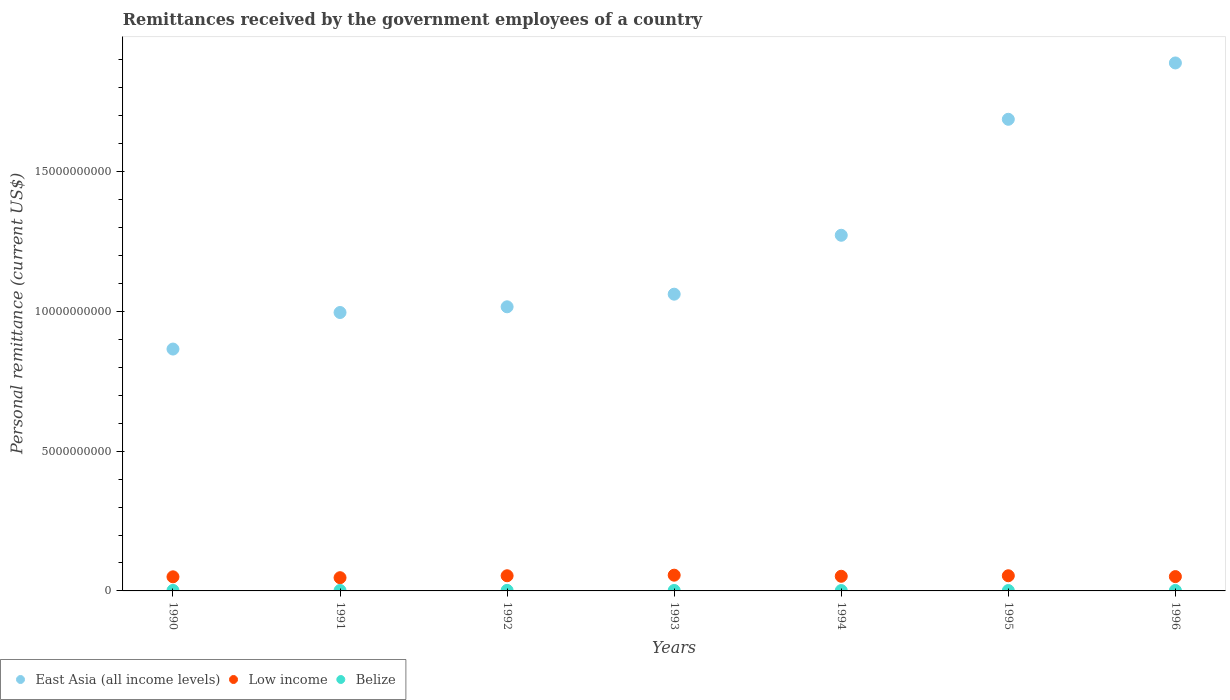How many different coloured dotlines are there?
Your response must be concise. 3. Is the number of dotlines equal to the number of legend labels?
Keep it short and to the point. Yes. What is the remittances received by the government employees in East Asia (all income levels) in 1995?
Your answer should be very brief. 1.69e+1. Across all years, what is the maximum remittances received by the government employees in East Asia (all income levels)?
Your answer should be very brief. 1.89e+1. Across all years, what is the minimum remittances received by the government employees in Belize?
Ensure brevity in your answer.  1.30e+07. What is the total remittances received by the government employees in Low income in the graph?
Offer a terse response. 3.66e+09. What is the difference between the remittances received by the government employees in East Asia (all income levels) in 1992 and that in 1993?
Your response must be concise. -4.52e+08. What is the difference between the remittances received by the government employees in Low income in 1991 and the remittances received by the government employees in Belize in 1990?
Provide a succinct answer. 4.55e+08. What is the average remittances received by the government employees in Low income per year?
Give a very brief answer. 5.23e+08. In the year 1992, what is the difference between the remittances received by the government employees in Low income and remittances received by the government employees in Belize?
Give a very brief answer. 5.23e+08. What is the ratio of the remittances received by the government employees in East Asia (all income levels) in 1993 to that in 1994?
Your response must be concise. 0.83. What is the difference between the highest and the second highest remittances received by the government employees in Low income?
Ensure brevity in your answer.  2.03e+07. What is the difference between the highest and the lowest remittances received by the government employees in Low income?
Your response must be concise. 8.98e+07. Is the sum of the remittances received by the government employees in East Asia (all income levels) in 1990 and 1992 greater than the maximum remittances received by the government employees in Belize across all years?
Your answer should be compact. Yes. Is it the case that in every year, the sum of the remittances received by the government employees in East Asia (all income levels) and remittances received by the government employees in Belize  is greater than the remittances received by the government employees in Low income?
Keep it short and to the point. Yes. Does the remittances received by the government employees in Belize monotonically increase over the years?
Your answer should be very brief. No. Is the remittances received by the government employees in Belize strictly less than the remittances received by the government employees in East Asia (all income levels) over the years?
Your answer should be very brief. Yes. How many dotlines are there?
Provide a short and direct response. 3. How many years are there in the graph?
Offer a very short reply. 7. Does the graph contain grids?
Offer a very short reply. No. Where does the legend appear in the graph?
Ensure brevity in your answer.  Bottom left. How many legend labels are there?
Your answer should be compact. 3. What is the title of the graph?
Keep it short and to the point. Remittances received by the government employees of a country. What is the label or title of the X-axis?
Keep it short and to the point. Years. What is the label or title of the Y-axis?
Keep it short and to the point. Personal remittance (current US$). What is the Personal remittance (current US$) in East Asia (all income levels) in 1990?
Provide a succinct answer. 8.65e+09. What is the Personal remittance (current US$) in Low income in 1990?
Your response must be concise. 5.04e+08. What is the Personal remittance (current US$) of Belize in 1990?
Provide a succinct answer. 1.85e+07. What is the Personal remittance (current US$) of East Asia (all income levels) in 1991?
Provide a succinct answer. 9.96e+09. What is the Personal remittance (current US$) of Low income in 1991?
Keep it short and to the point. 4.73e+08. What is the Personal remittance (current US$) of Belize in 1991?
Offer a very short reply. 1.56e+07. What is the Personal remittance (current US$) of East Asia (all income levels) in 1992?
Offer a terse response. 1.02e+1. What is the Personal remittance (current US$) of Low income in 1992?
Offer a terse response. 5.43e+08. What is the Personal remittance (current US$) of Belize in 1992?
Your answer should be compact. 1.98e+07. What is the Personal remittance (current US$) in East Asia (all income levels) in 1993?
Provide a short and direct response. 1.06e+1. What is the Personal remittance (current US$) of Low income in 1993?
Your answer should be very brief. 5.63e+08. What is the Personal remittance (current US$) in Belize in 1993?
Offer a very short reply. 1.65e+07. What is the Personal remittance (current US$) in East Asia (all income levels) in 1994?
Offer a terse response. 1.27e+1. What is the Personal remittance (current US$) in Low income in 1994?
Provide a short and direct response. 5.24e+08. What is the Personal remittance (current US$) in Belize in 1994?
Give a very brief answer. 1.30e+07. What is the Personal remittance (current US$) in East Asia (all income levels) in 1995?
Keep it short and to the point. 1.69e+1. What is the Personal remittance (current US$) of Low income in 1995?
Offer a terse response. 5.43e+08. What is the Personal remittance (current US$) in Belize in 1995?
Offer a terse response. 1.39e+07. What is the Personal remittance (current US$) of East Asia (all income levels) in 1996?
Provide a succinct answer. 1.89e+1. What is the Personal remittance (current US$) of Low income in 1996?
Provide a short and direct response. 5.12e+08. What is the Personal remittance (current US$) of Belize in 1996?
Offer a very short reply. 1.72e+07. Across all years, what is the maximum Personal remittance (current US$) of East Asia (all income levels)?
Ensure brevity in your answer.  1.89e+1. Across all years, what is the maximum Personal remittance (current US$) in Low income?
Offer a terse response. 5.63e+08. Across all years, what is the maximum Personal remittance (current US$) of Belize?
Your answer should be compact. 1.98e+07. Across all years, what is the minimum Personal remittance (current US$) of East Asia (all income levels)?
Your answer should be very brief. 8.65e+09. Across all years, what is the minimum Personal remittance (current US$) of Low income?
Offer a terse response. 4.73e+08. Across all years, what is the minimum Personal remittance (current US$) in Belize?
Offer a terse response. 1.30e+07. What is the total Personal remittance (current US$) of East Asia (all income levels) in the graph?
Ensure brevity in your answer.  8.79e+1. What is the total Personal remittance (current US$) of Low income in the graph?
Ensure brevity in your answer.  3.66e+09. What is the total Personal remittance (current US$) of Belize in the graph?
Give a very brief answer. 1.14e+08. What is the difference between the Personal remittance (current US$) of East Asia (all income levels) in 1990 and that in 1991?
Offer a terse response. -1.31e+09. What is the difference between the Personal remittance (current US$) of Low income in 1990 and that in 1991?
Offer a terse response. 3.10e+07. What is the difference between the Personal remittance (current US$) in Belize in 1990 and that in 1991?
Ensure brevity in your answer.  2.85e+06. What is the difference between the Personal remittance (current US$) of East Asia (all income levels) in 1990 and that in 1992?
Provide a succinct answer. -1.51e+09. What is the difference between the Personal remittance (current US$) in Low income in 1990 and that in 1992?
Make the answer very short. -3.84e+07. What is the difference between the Personal remittance (current US$) in Belize in 1990 and that in 1992?
Your answer should be compact. -1.30e+06. What is the difference between the Personal remittance (current US$) of East Asia (all income levels) in 1990 and that in 1993?
Your answer should be very brief. -1.96e+09. What is the difference between the Personal remittance (current US$) of Low income in 1990 and that in 1993?
Your response must be concise. -5.88e+07. What is the difference between the Personal remittance (current US$) of Belize in 1990 and that in 1993?
Provide a short and direct response. 1.95e+06. What is the difference between the Personal remittance (current US$) of East Asia (all income levels) in 1990 and that in 1994?
Provide a short and direct response. -4.07e+09. What is the difference between the Personal remittance (current US$) of Low income in 1990 and that in 1994?
Give a very brief answer. -1.96e+07. What is the difference between the Personal remittance (current US$) in Belize in 1990 and that in 1994?
Make the answer very short. 5.48e+06. What is the difference between the Personal remittance (current US$) in East Asia (all income levels) in 1990 and that in 1995?
Offer a terse response. -8.22e+09. What is the difference between the Personal remittance (current US$) in Low income in 1990 and that in 1995?
Offer a very short reply. -3.85e+07. What is the difference between the Personal remittance (current US$) of Belize in 1990 and that in 1995?
Ensure brevity in your answer.  4.55e+06. What is the difference between the Personal remittance (current US$) in East Asia (all income levels) in 1990 and that in 1996?
Ensure brevity in your answer.  -1.02e+1. What is the difference between the Personal remittance (current US$) in Low income in 1990 and that in 1996?
Make the answer very short. -8.04e+06. What is the difference between the Personal remittance (current US$) of Belize in 1990 and that in 1996?
Give a very brief answer. 1.20e+06. What is the difference between the Personal remittance (current US$) of East Asia (all income levels) in 1991 and that in 1992?
Provide a succinct answer. -2.04e+08. What is the difference between the Personal remittance (current US$) in Low income in 1991 and that in 1992?
Your response must be concise. -6.94e+07. What is the difference between the Personal remittance (current US$) in Belize in 1991 and that in 1992?
Your answer should be very brief. -4.15e+06. What is the difference between the Personal remittance (current US$) in East Asia (all income levels) in 1991 and that in 1993?
Your answer should be compact. -6.56e+08. What is the difference between the Personal remittance (current US$) of Low income in 1991 and that in 1993?
Make the answer very short. -8.98e+07. What is the difference between the Personal remittance (current US$) in Belize in 1991 and that in 1993?
Offer a very short reply. -9.00e+05. What is the difference between the Personal remittance (current US$) in East Asia (all income levels) in 1991 and that in 1994?
Offer a very short reply. -2.76e+09. What is the difference between the Personal remittance (current US$) in Low income in 1991 and that in 1994?
Give a very brief answer. -5.06e+07. What is the difference between the Personal remittance (current US$) in Belize in 1991 and that in 1994?
Your answer should be compact. 2.63e+06. What is the difference between the Personal remittance (current US$) in East Asia (all income levels) in 1991 and that in 1995?
Your answer should be compact. -6.91e+09. What is the difference between the Personal remittance (current US$) in Low income in 1991 and that in 1995?
Provide a short and direct response. -6.95e+07. What is the difference between the Personal remittance (current US$) of Belize in 1991 and that in 1995?
Give a very brief answer. 1.70e+06. What is the difference between the Personal remittance (current US$) in East Asia (all income levels) in 1991 and that in 1996?
Your answer should be compact. -8.93e+09. What is the difference between the Personal remittance (current US$) in Low income in 1991 and that in 1996?
Offer a very short reply. -3.91e+07. What is the difference between the Personal remittance (current US$) in Belize in 1991 and that in 1996?
Make the answer very short. -1.65e+06. What is the difference between the Personal remittance (current US$) in East Asia (all income levels) in 1992 and that in 1993?
Provide a succinct answer. -4.52e+08. What is the difference between the Personal remittance (current US$) in Low income in 1992 and that in 1993?
Your response must be concise. -2.04e+07. What is the difference between the Personal remittance (current US$) of Belize in 1992 and that in 1993?
Ensure brevity in your answer.  3.25e+06. What is the difference between the Personal remittance (current US$) in East Asia (all income levels) in 1992 and that in 1994?
Provide a short and direct response. -2.56e+09. What is the difference between the Personal remittance (current US$) of Low income in 1992 and that in 1994?
Your answer should be compact. 1.88e+07. What is the difference between the Personal remittance (current US$) of Belize in 1992 and that in 1994?
Keep it short and to the point. 6.78e+06. What is the difference between the Personal remittance (current US$) in East Asia (all income levels) in 1992 and that in 1995?
Ensure brevity in your answer.  -6.71e+09. What is the difference between the Personal remittance (current US$) of Low income in 1992 and that in 1995?
Provide a succinct answer. -9.84e+04. What is the difference between the Personal remittance (current US$) of Belize in 1992 and that in 1995?
Provide a short and direct response. 5.85e+06. What is the difference between the Personal remittance (current US$) in East Asia (all income levels) in 1992 and that in 1996?
Provide a succinct answer. -8.73e+09. What is the difference between the Personal remittance (current US$) in Low income in 1992 and that in 1996?
Give a very brief answer. 3.03e+07. What is the difference between the Personal remittance (current US$) of Belize in 1992 and that in 1996?
Your answer should be very brief. 2.50e+06. What is the difference between the Personal remittance (current US$) in East Asia (all income levels) in 1993 and that in 1994?
Give a very brief answer. -2.11e+09. What is the difference between the Personal remittance (current US$) of Low income in 1993 and that in 1994?
Offer a very short reply. 3.92e+07. What is the difference between the Personal remittance (current US$) in Belize in 1993 and that in 1994?
Your response must be concise. 3.53e+06. What is the difference between the Personal remittance (current US$) of East Asia (all income levels) in 1993 and that in 1995?
Ensure brevity in your answer.  -6.26e+09. What is the difference between the Personal remittance (current US$) of Low income in 1993 and that in 1995?
Ensure brevity in your answer.  2.03e+07. What is the difference between the Personal remittance (current US$) of Belize in 1993 and that in 1995?
Provide a succinct answer. 2.60e+06. What is the difference between the Personal remittance (current US$) of East Asia (all income levels) in 1993 and that in 1996?
Offer a terse response. -8.27e+09. What is the difference between the Personal remittance (current US$) in Low income in 1993 and that in 1996?
Offer a terse response. 5.07e+07. What is the difference between the Personal remittance (current US$) of Belize in 1993 and that in 1996?
Keep it short and to the point. -7.50e+05. What is the difference between the Personal remittance (current US$) of East Asia (all income levels) in 1994 and that in 1995?
Your answer should be very brief. -4.15e+09. What is the difference between the Personal remittance (current US$) of Low income in 1994 and that in 1995?
Offer a very short reply. -1.89e+07. What is the difference between the Personal remittance (current US$) in Belize in 1994 and that in 1995?
Provide a short and direct response. -9.28e+05. What is the difference between the Personal remittance (current US$) in East Asia (all income levels) in 1994 and that in 1996?
Keep it short and to the point. -6.17e+09. What is the difference between the Personal remittance (current US$) of Low income in 1994 and that in 1996?
Your answer should be compact. 1.15e+07. What is the difference between the Personal remittance (current US$) of Belize in 1994 and that in 1996?
Offer a terse response. -4.28e+06. What is the difference between the Personal remittance (current US$) in East Asia (all income levels) in 1995 and that in 1996?
Give a very brief answer. -2.02e+09. What is the difference between the Personal remittance (current US$) of Low income in 1995 and that in 1996?
Make the answer very short. 3.04e+07. What is the difference between the Personal remittance (current US$) of Belize in 1995 and that in 1996?
Your answer should be compact. -3.35e+06. What is the difference between the Personal remittance (current US$) of East Asia (all income levels) in 1990 and the Personal remittance (current US$) of Low income in 1991?
Offer a terse response. 8.18e+09. What is the difference between the Personal remittance (current US$) of East Asia (all income levels) in 1990 and the Personal remittance (current US$) of Belize in 1991?
Offer a terse response. 8.64e+09. What is the difference between the Personal remittance (current US$) in Low income in 1990 and the Personal remittance (current US$) in Belize in 1991?
Make the answer very short. 4.89e+08. What is the difference between the Personal remittance (current US$) of East Asia (all income levels) in 1990 and the Personal remittance (current US$) of Low income in 1992?
Provide a short and direct response. 8.11e+09. What is the difference between the Personal remittance (current US$) in East Asia (all income levels) in 1990 and the Personal remittance (current US$) in Belize in 1992?
Provide a succinct answer. 8.63e+09. What is the difference between the Personal remittance (current US$) of Low income in 1990 and the Personal remittance (current US$) of Belize in 1992?
Your answer should be very brief. 4.85e+08. What is the difference between the Personal remittance (current US$) of East Asia (all income levels) in 1990 and the Personal remittance (current US$) of Low income in 1993?
Give a very brief answer. 8.09e+09. What is the difference between the Personal remittance (current US$) of East Asia (all income levels) in 1990 and the Personal remittance (current US$) of Belize in 1993?
Your response must be concise. 8.64e+09. What is the difference between the Personal remittance (current US$) in Low income in 1990 and the Personal remittance (current US$) in Belize in 1993?
Make the answer very short. 4.88e+08. What is the difference between the Personal remittance (current US$) of East Asia (all income levels) in 1990 and the Personal remittance (current US$) of Low income in 1994?
Give a very brief answer. 8.13e+09. What is the difference between the Personal remittance (current US$) in East Asia (all income levels) in 1990 and the Personal remittance (current US$) in Belize in 1994?
Give a very brief answer. 8.64e+09. What is the difference between the Personal remittance (current US$) of Low income in 1990 and the Personal remittance (current US$) of Belize in 1994?
Provide a short and direct response. 4.91e+08. What is the difference between the Personal remittance (current US$) in East Asia (all income levels) in 1990 and the Personal remittance (current US$) in Low income in 1995?
Your answer should be very brief. 8.11e+09. What is the difference between the Personal remittance (current US$) in East Asia (all income levels) in 1990 and the Personal remittance (current US$) in Belize in 1995?
Offer a terse response. 8.64e+09. What is the difference between the Personal remittance (current US$) in Low income in 1990 and the Personal remittance (current US$) in Belize in 1995?
Make the answer very short. 4.90e+08. What is the difference between the Personal remittance (current US$) of East Asia (all income levels) in 1990 and the Personal remittance (current US$) of Low income in 1996?
Ensure brevity in your answer.  8.14e+09. What is the difference between the Personal remittance (current US$) in East Asia (all income levels) in 1990 and the Personal remittance (current US$) in Belize in 1996?
Keep it short and to the point. 8.64e+09. What is the difference between the Personal remittance (current US$) in Low income in 1990 and the Personal remittance (current US$) in Belize in 1996?
Keep it short and to the point. 4.87e+08. What is the difference between the Personal remittance (current US$) in East Asia (all income levels) in 1991 and the Personal remittance (current US$) in Low income in 1992?
Keep it short and to the point. 9.42e+09. What is the difference between the Personal remittance (current US$) of East Asia (all income levels) in 1991 and the Personal remittance (current US$) of Belize in 1992?
Your answer should be very brief. 9.94e+09. What is the difference between the Personal remittance (current US$) in Low income in 1991 and the Personal remittance (current US$) in Belize in 1992?
Your response must be concise. 4.54e+08. What is the difference between the Personal remittance (current US$) of East Asia (all income levels) in 1991 and the Personal remittance (current US$) of Low income in 1993?
Keep it short and to the point. 9.40e+09. What is the difference between the Personal remittance (current US$) of East Asia (all income levels) in 1991 and the Personal remittance (current US$) of Belize in 1993?
Give a very brief answer. 9.95e+09. What is the difference between the Personal remittance (current US$) of Low income in 1991 and the Personal remittance (current US$) of Belize in 1993?
Your answer should be compact. 4.57e+08. What is the difference between the Personal remittance (current US$) in East Asia (all income levels) in 1991 and the Personal remittance (current US$) in Low income in 1994?
Keep it short and to the point. 9.44e+09. What is the difference between the Personal remittance (current US$) of East Asia (all income levels) in 1991 and the Personal remittance (current US$) of Belize in 1994?
Provide a short and direct response. 9.95e+09. What is the difference between the Personal remittance (current US$) of Low income in 1991 and the Personal remittance (current US$) of Belize in 1994?
Your answer should be compact. 4.60e+08. What is the difference between the Personal remittance (current US$) of East Asia (all income levels) in 1991 and the Personal remittance (current US$) of Low income in 1995?
Your answer should be compact. 9.42e+09. What is the difference between the Personal remittance (current US$) of East Asia (all income levels) in 1991 and the Personal remittance (current US$) of Belize in 1995?
Ensure brevity in your answer.  9.95e+09. What is the difference between the Personal remittance (current US$) in Low income in 1991 and the Personal remittance (current US$) in Belize in 1995?
Offer a terse response. 4.59e+08. What is the difference between the Personal remittance (current US$) in East Asia (all income levels) in 1991 and the Personal remittance (current US$) in Low income in 1996?
Ensure brevity in your answer.  9.45e+09. What is the difference between the Personal remittance (current US$) of East Asia (all income levels) in 1991 and the Personal remittance (current US$) of Belize in 1996?
Provide a succinct answer. 9.94e+09. What is the difference between the Personal remittance (current US$) of Low income in 1991 and the Personal remittance (current US$) of Belize in 1996?
Provide a short and direct response. 4.56e+08. What is the difference between the Personal remittance (current US$) in East Asia (all income levels) in 1992 and the Personal remittance (current US$) in Low income in 1993?
Ensure brevity in your answer.  9.60e+09. What is the difference between the Personal remittance (current US$) in East Asia (all income levels) in 1992 and the Personal remittance (current US$) in Belize in 1993?
Provide a succinct answer. 1.01e+1. What is the difference between the Personal remittance (current US$) of Low income in 1992 and the Personal remittance (current US$) of Belize in 1993?
Your answer should be very brief. 5.26e+08. What is the difference between the Personal remittance (current US$) in East Asia (all income levels) in 1992 and the Personal remittance (current US$) in Low income in 1994?
Keep it short and to the point. 9.64e+09. What is the difference between the Personal remittance (current US$) in East Asia (all income levels) in 1992 and the Personal remittance (current US$) in Belize in 1994?
Make the answer very short. 1.02e+1. What is the difference between the Personal remittance (current US$) in Low income in 1992 and the Personal remittance (current US$) in Belize in 1994?
Keep it short and to the point. 5.30e+08. What is the difference between the Personal remittance (current US$) of East Asia (all income levels) in 1992 and the Personal remittance (current US$) of Low income in 1995?
Ensure brevity in your answer.  9.62e+09. What is the difference between the Personal remittance (current US$) in East Asia (all income levels) in 1992 and the Personal remittance (current US$) in Belize in 1995?
Ensure brevity in your answer.  1.02e+1. What is the difference between the Personal remittance (current US$) of Low income in 1992 and the Personal remittance (current US$) of Belize in 1995?
Keep it short and to the point. 5.29e+08. What is the difference between the Personal remittance (current US$) of East Asia (all income levels) in 1992 and the Personal remittance (current US$) of Low income in 1996?
Provide a short and direct response. 9.65e+09. What is the difference between the Personal remittance (current US$) in East Asia (all income levels) in 1992 and the Personal remittance (current US$) in Belize in 1996?
Offer a very short reply. 1.01e+1. What is the difference between the Personal remittance (current US$) of Low income in 1992 and the Personal remittance (current US$) of Belize in 1996?
Your response must be concise. 5.25e+08. What is the difference between the Personal remittance (current US$) of East Asia (all income levels) in 1993 and the Personal remittance (current US$) of Low income in 1994?
Ensure brevity in your answer.  1.01e+1. What is the difference between the Personal remittance (current US$) in East Asia (all income levels) in 1993 and the Personal remittance (current US$) in Belize in 1994?
Keep it short and to the point. 1.06e+1. What is the difference between the Personal remittance (current US$) in Low income in 1993 and the Personal remittance (current US$) in Belize in 1994?
Offer a terse response. 5.50e+08. What is the difference between the Personal remittance (current US$) of East Asia (all income levels) in 1993 and the Personal remittance (current US$) of Low income in 1995?
Keep it short and to the point. 1.01e+1. What is the difference between the Personal remittance (current US$) of East Asia (all income levels) in 1993 and the Personal remittance (current US$) of Belize in 1995?
Keep it short and to the point. 1.06e+1. What is the difference between the Personal remittance (current US$) in Low income in 1993 and the Personal remittance (current US$) in Belize in 1995?
Make the answer very short. 5.49e+08. What is the difference between the Personal remittance (current US$) in East Asia (all income levels) in 1993 and the Personal remittance (current US$) in Low income in 1996?
Your answer should be very brief. 1.01e+1. What is the difference between the Personal remittance (current US$) of East Asia (all income levels) in 1993 and the Personal remittance (current US$) of Belize in 1996?
Make the answer very short. 1.06e+1. What is the difference between the Personal remittance (current US$) of Low income in 1993 and the Personal remittance (current US$) of Belize in 1996?
Provide a succinct answer. 5.46e+08. What is the difference between the Personal remittance (current US$) of East Asia (all income levels) in 1994 and the Personal remittance (current US$) of Low income in 1995?
Offer a very short reply. 1.22e+1. What is the difference between the Personal remittance (current US$) of East Asia (all income levels) in 1994 and the Personal remittance (current US$) of Belize in 1995?
Keep it short and to the point. 1.27e+1. What is the difference between the Personal remittance (current US$) in Low income in 1994 and the Personal remittance (current US$) in Belize in 1995?
Offer a very short reply. 5.10e+08. What is the difference between the Personal remittance (current US$) of East Asia (all income levels) in 1994 and the Personal remittance (current US$) of Low income in 1996?
Offer a terse response. 1.22e+1. What is the difference between the Personal remittance (current US$) in East Asia (all income levels) in 1994 and the Personal remittance (current US$) in Belize in 1996?
Your answer should be compact. 1.27e+1. What is the difference between the Personal remittance (current US$) in Low income in 1994 and the Personal remittance (current US$) in Belize in 1996?
Offer a very short reply. 5.07e+08. What is the difference between the Personal remittance (current US$) in East Asia (all income levels) in 1995 and the Personal remittance (current US$) in Low income in 1996?
Your answer should be compact. 1.64e+1. What is the difference between the Personal remittance (current US$) of East Asia (all income levels) in 1995 and the Personal remittance (current US$) of Belize in 1996?
Provide a succinct answer. 1.69e+1. What is the difference between the Personal remittance (current US$) of Low income in 1995 and the Personal remittance (current US$) of Belize in 1996?
Your response must be concise. 5.26e+08. What is the average Personal remittance (current US$) in East Asia (all income levels) per year?
Your response must be concise. 1.26e+1. What is the average Personal remittance (current US$) in Low income per year?
Your answer should be very brief. 5.23e+08. What is the average Personal remittance (current US$) in Belize per year?
Provide a short and direct response. 1.63e+07. In the year 1990, what is the difference between the Personal remittance (current US$) in East Asia (all income levels) and Personal remittance (current US$) in Low income?
Give a very brief answer. 8.15e+09. In the year 1990, what is the difference between the Personal remittance (current US$) of East Asia (all income levels) and Personal remittance (current US$) of Belize?
Provide a succinct answer. 8.64e+09. In the year 1990, what is the difference between the Personal remittance (current US$) in Low income and Personal remittance (current US$) in Belize?
Your answer should be compact. 4.86e+08. In the year 1991, what is the difference between the Personal remittance (current US$) in East Asia (all income levels) and Personal remittance (current US$) in Low income?
Your answer should be compact. 9.49e+09. In the year 1991, what is the difference between the Personal remittance (current US$) in East Asia (all income levels) and Personal remittance (current US$) in Belize?
Your response must be concise. 9.95e+09. In the year 1991, what is the difference between the Personal remittance (current US$) of Low income and Personal remittance (current US$) of Belize?
Your response must be concise. 4.58e+08. In the year 1992, what is the difference between the Personal remittance (current US$) in East Asia (all income levels) and Personal remittance (current US$) in Low income?
Your answer should be compact. 9.62e+09. In the year 1992, what is the difference between the Personal remittance (current US$) of East Asia (all income levels) and Personal remittance (current US$) of Belize?
Your response must be concise. 1.01e+1. In the year 1992, what is the difference between the Personal remittance (current US$) in Low income and Personal remittance (current US$) in Belize?
Your response must be concise. 5.23e+08. In the year 1993, what is the difference between the Personal remittance (current US$) of East Asia (all income levels) and Personal remittance (current US$) of Low income?
Your response must be concise. 1.01e+1. In the year 1993, what is the difference between the Personal remittance (current US$) of East Asia (all income levels) and Personal remittance (current US$) of Belize?
Your response must be concise. 1.06e+1. In the year 1993, what is the difference between the Personal remittance (current US$) in Low income and Personal remittance (current US$) in Belize?
Give a very brief answer. 5.47e+08. In the year 1994, what is the difference between the Personal remittance (current US$) of East Asia (all income levels) and Personal remittance (current US$) of Low income?
Keep it short and to the point. 1.22e+1. In the year 1994, what is the difference between the Personal remittance (current US$) of East Asia (all income levels) and Personal remittance (current US$) of Belize?
Ensure brevity in your answer.  1.27e+1. In the year 1994, what is the difference between the Personal remittance (current US$) in Low income and Personal remittance (current US$) in Belize?
Provide a short and direct response. 5.11e+08. In the year 1995, what is the difference between the Personal remittance (current US$) of East Asia (all income levels) and Personal remittance (current US$) of Low income?
Ensure brevity in your answer.  1.63e+1. In the year 1995, what is the difference between the Personal remittance (current US$) in East Asia (all income levels) and Personal remittance (current US$) in Belize?
Provide a succinct answer. 1.69e+1. In the year 1995, what is the difference between the Personal remittance (current US$) of Low income and Personal remittance (current US$) of Belize?
Offer a very short reply. 5.29e+08. In the year 1996, what is the difference between the Personal remittance (current US$) of East Asia (all income levels) and Personal remittance (current US$) of Low income?
Give a very brief answer. 1.84e+1. In the year 1996, what is the difference between the Personal remittance (current US$) of East Asia (all income levels) and Personal remittance (current US$) of Belize?
Make the answer very short. 1.89e+1. In the year 1996, what is the difference between the Personal remittance (current US$) of Low income and Personal remittance (current US$) of Belize?
Your response must be concise. 4.95e+08. What is the ratio of the Personal remittance (current US$) in East Asia (all income levels) in 1990 to that in 1991?
Give a very brief answer. 0.87. What is the ratio of the Personal remittance (current US$) in Low income in 1990 to that in 1991?
Your response must be concise. 1.07. What is the ratio of the Personal remittance (current US$) of Belize in 1990 to that in 1991?
Your answer should be very brief. 1.18. What is the ratio of the Personal remittance (current US$) of East Asia (all income levels) in 1990 to that in 1992?
Provide a short and direct response. 0.85. What is the ratio of the Personal remittance (current US$) in Low income in 1990 to that in 1992?
Your answer should be very brief. 0.93. What is the ratio of the Personal remittance (current US$) of Belize in 1990 to that in 1992?
Make the answer very short. 0.93. What is the ratio of the Personal remittance (current US$) in East Asia (all income levels) in 1990 to that in 1993?
Provide a succinct answer. 0.82. What is the ratio of the Personal remittance (current US$) in Low income in 1990 to that in 1993?
Provide a short and direct response. 0.9. What is the ratio of the Personal remittance (current US$) of Belize in 1990 to that in 1993?
Provide a succinct answer. 1.12. What is the ratio of the Personal remittance (current US$) in East Asia (all income levels) in 1990 to that in 1994?
Provide a succinct answer. 0.68. What is the ratio of the Personal remittance (current US$) in Low income in 1990 to that in 1994?
Ensure brevity in your answer.  0.96. What is the ratio of the Personal remittance (current US$) of Belize in 1990 to that in 1994?
Your answer should be very brief. 1.42. What is the ratio of the Personal remittance (current US$) of East Asia (all income levels) in 1990 to that in 1995?
Ensure brevity in your answer.  0.51. What is the ratio of the Personal remittance (current US$) of Low income in 1990 to that in 1995?
Provide a short and direct response. 0.93. What is the ratio of the Personal remittance (current US$) in Belize in 1990 to that in 1995?
Offer a very short reply. 1.33. What is the ratio of the Personal remittance (current US$) of East Asia (all income levels) in 1990 to that in 1996?
Offer a terse response. 0.46. What is the ratio of the Personal remittance (current US$) in Low income in 1990 to that in 1996?
Give a very brief answer. 0.98. What is the ratio of the Personal remittance (current US$) in Belize in 1990 to that in 1996?
Keep it short and to the point. 1.07. What is the ratio of the Personal remittance (current US$) of East Asia (all income levels) in 1991 to that in 1992?
Your answer should be compact. 0.98. What is the ratio of the Personal remittance (current US$) in Low income in 1991 to that in 1992?
Your answer should be compact. 0.87. What is the ratio of the Personal remittance (current US$) of Belize in 1991 to that in 1992?
Offer a very short reply. 0.79. What is the ratio of the Personal remittance (current US$) in East Asia (all income levels) in 1991 to that in 1993?
Make the answer very short. 0.94. What is the ratio of the Personal remittance (current US$) in Low income in 1991 to that in 1993?
Make the answer very short. 0.84. What is the ratio of the Personal remittance (current US$) in Belize in 1991 to that in 1993?
Offer a very short reply. 0.95. What is the ratio of the Personal remittance (current US$) of East Asia (all income levels) in 1991 to that in 1994?
Your answer should be compact. 0.78. What is the ratio of the Personal remittance (current US$) in Low income in 1991 to that in 1994?
Your answer should be compact. 0.9. What is the ratio of the Personal remittance (current US$) of Belize in 1991 to that in 1994?
Give a very brief answer. 1.2. What is the ratio of the Personal remittance (current US$) of East Asia (all income levels) in 1991 to that in 1995?
Offer a terse response. 0.59. What is the ratio of the Personal remittance (current US$) in Low income in 1991 to that in 1995?
Keep it short and to the point. 0.87. What is the ratio of the Personal remittance (current US$) of Belize in 1991 to that in 1995?
Offer a very short reply. 1.12. What is the ratio of the Personal remittance (current US$) of East Asia (all income levels) in 1991 to that in 1996?
Your response must be concise. 0.53. What is the ratio of the Personal remittance (current US$) of Low income in 1991 to that in 1996?
Your answer should be compact. 0.92. What is the ratio of the Personal remittance (current US$) of Belize in 1991 to that in 1996?
Offer a very short reply. 0.9. What is the ratio of the Personal remittance (current US$) of East Asia (all income levels) in 1992 to that in 1993?
Give a very brief answer. 0.96. What is the ratio of the Personal remittance (current US$) of Low income in 1992 to that in 1993?
Your response must be concise. 0.96. What is the ratio of the Personal remittance (current US$) of Belize in 1992 to that in 1993?
Your answer should be very brief. 1.2. What is the ratio of the Personal remittance (current US$) in East Asia (all income levels) in 1992 to that in 1994?
Ensure brevity in your answer.  0.8. What is the ratio of the Personal remittance (current US$) in Low income in 1992 to that in 1994?
Make the answer very short. 1.04. What is the ratio of the Personal remittance (current US$) in Belize in 1992 to that in 1994?
Offer a very short reply. 1.52. What is the ratio of the Personal remittance (current US$) of East Asia (all income levels) in 1992 to that in 1995?
Ensure brevity in your answer.  0.6. What is the ratio of the Personal remittance (current US$) of Low income in 1992 to that in 1995?
Provide a short and direct response. 1. What is the ratio of the Personal remittance (current US$) in Belize in 1992 to that in 1995?
Provide a succinct answer. 1.42. What is the ratio of the Personal remittance (current US$) of East Asia (all income levels) in 1992 to that in 1996?
Keep it short and to the point. 0.54. What is the ratio of the Personal remittance (current US$) of Low income in 1992 to that in 1996?
Your response must be concise. 1.06. What is the ratio of the Personal remittance (current US$) in Belize in 1992 to that in 1996?
Offer a terse response. 1.14. What is the ratio of the Personal remittance (current US$) of East Asia (all income levels) in 1993 to that in 1994?
Offer a very short reply. 0.83. What is the ratio of the Personal remittance (current US$) in Low income in 1993 to that in 1994?
Provide a short and direct response. 1.07. What is the ratio of the Personal remittance (current US$) of Belize in 1993 to that in 1994?
Keep it short and to the point. 1.27. What is the ratio of the Personal remittance (current US$) in East Asia (all income levels) in 1993 to that in 1995?
Ensure brevity in your answer.  0.63. What is the ratio of the Personal remittance (current US$) of Low income in 1993 to that in 1995?
Your response must be concise. 1.04. What is the ratio of the Personal remittance (current US$) of Belize in 1993 to that in 1995?
Offer a terse response. 1.19. What is the ratio of the Personal remittance (current US$) in East Asia (all income levels) in 1993 to that in 1996?
Make the answer very short. 0.56. What is the ratio of the Personal remittance (current US$) of Low income in 1993 to that in 1996?
Offer a terse response. 1.1. What is the ratio of the Personal remittance (current US$) in Belize in 1993 to that in 1996?
Keep it short and to the point. 0.96. What is the ratio of the Personal remittance (current US$) in East Asia (all income levels) in 1994 to that in 1995?
Provide a succinct answer. 0.75. What is the ratio of the Personal remittance (current US$) in Low income in 1994 to that in 1995?
Offer a very short reply. 0.97. What is the ratio of the Personal remittance (current US$) of Belize in 1994 to that in 1995?
Your response must be concise. 0.93. What is the ratio of the Personal remittance (current US$) in East Asia (all income levels) in 1994 to that in 1996?
Offer a terse response. 0.67. What is the ratio of the Personal remittance (current US$) of Low income in 1994 to that in 1996?
Ensure brevity in your answer.  1.02. What is the ratio of the Personal remittance (current US$) in Belize in 1994 to that in 1996?
Give a very brief answer. 0.75. What is the ratio of the Personal remittance (current US$) of East Asia (all income levels) in 1995 to that in 1996?
Provide a short and direct response. 0.89. What is the ratio of the Personal remittance (current US$) in Low income in 1995 to that in 1996?
Provide a short and direct response. 1.06. What is the ratio of the Personal remittance (current US$) in Belize in 1995 to that in 1996?
Your answer should be compact. 0.81. What is the difference between the highest and the second highest Personal remittance (current US$) of East Asia (all income levels)?
Offer a very short reply. 2.02e+09. What is the difference between the highest and the second highest Personal remittance (current US$) in Low income?
Provide a short and direct response. 2.03e+07. What is the difference between the highest and the second highest Personal remittance (current US$) in Belize?
Make the answer very short. 1.30e+06. What is the difference between the highest and the lowest Personal remittance (current US$) of East Asia (all income levels)?
Your answer should be very brief. 1.02e+1. What is the difference between the highest and the lowest Personal remittance (current US$) in Low income?
Provide a short and direct response. 8.98e+07. What is the difference between the highest and the lowest Personal remittance (current US$) in Belize?
Ensure brevity in your answer.  6.78e+06. 